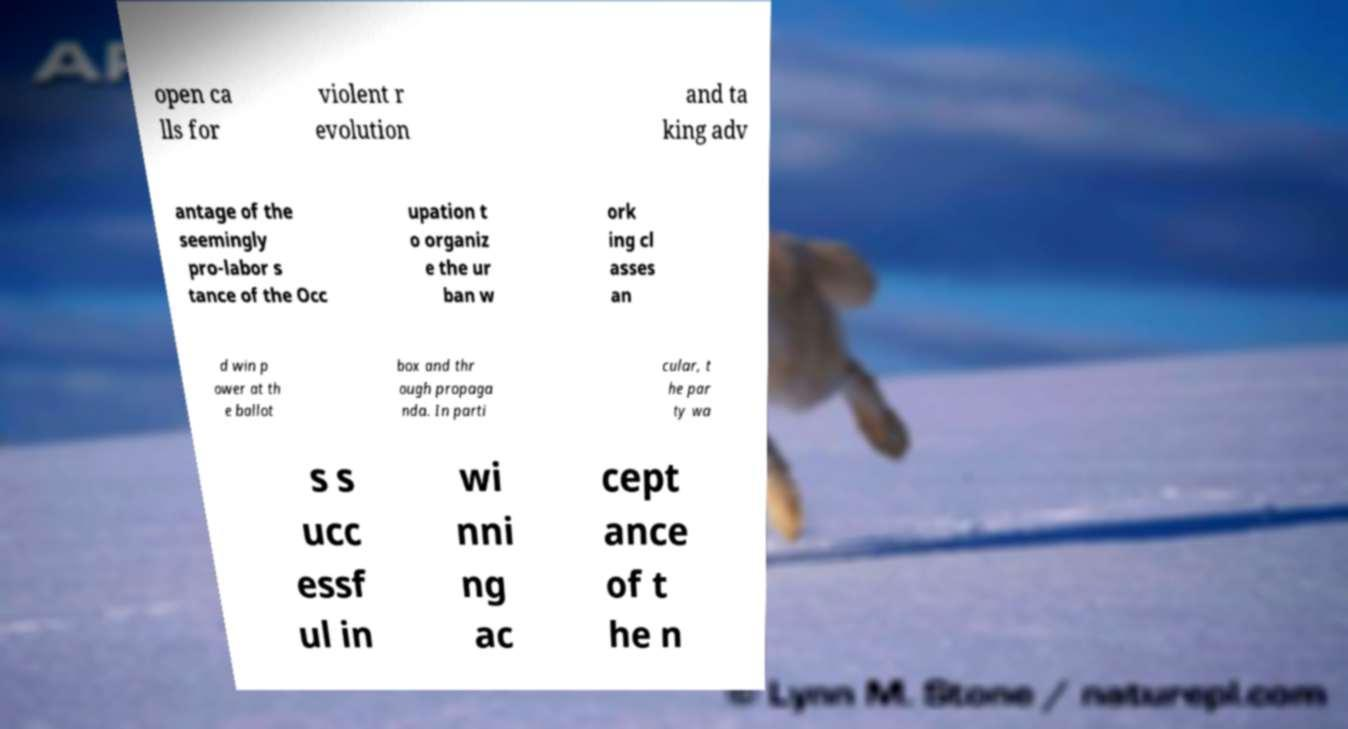There's text embedded in this image that I need extracted. Can you transcribe it verbatim? open ca lls for violent r evolution and ta king adv antage of the seemingly pro-labor s tance of the Occ upation t o organiz e the ur ban w ork ing cl asses an d win p ower at th e ballot box and thr ough propaga nda. In parti cular, t he par ty wa s s ucc essf ul in wi nni ng ac cept ance of t he n 